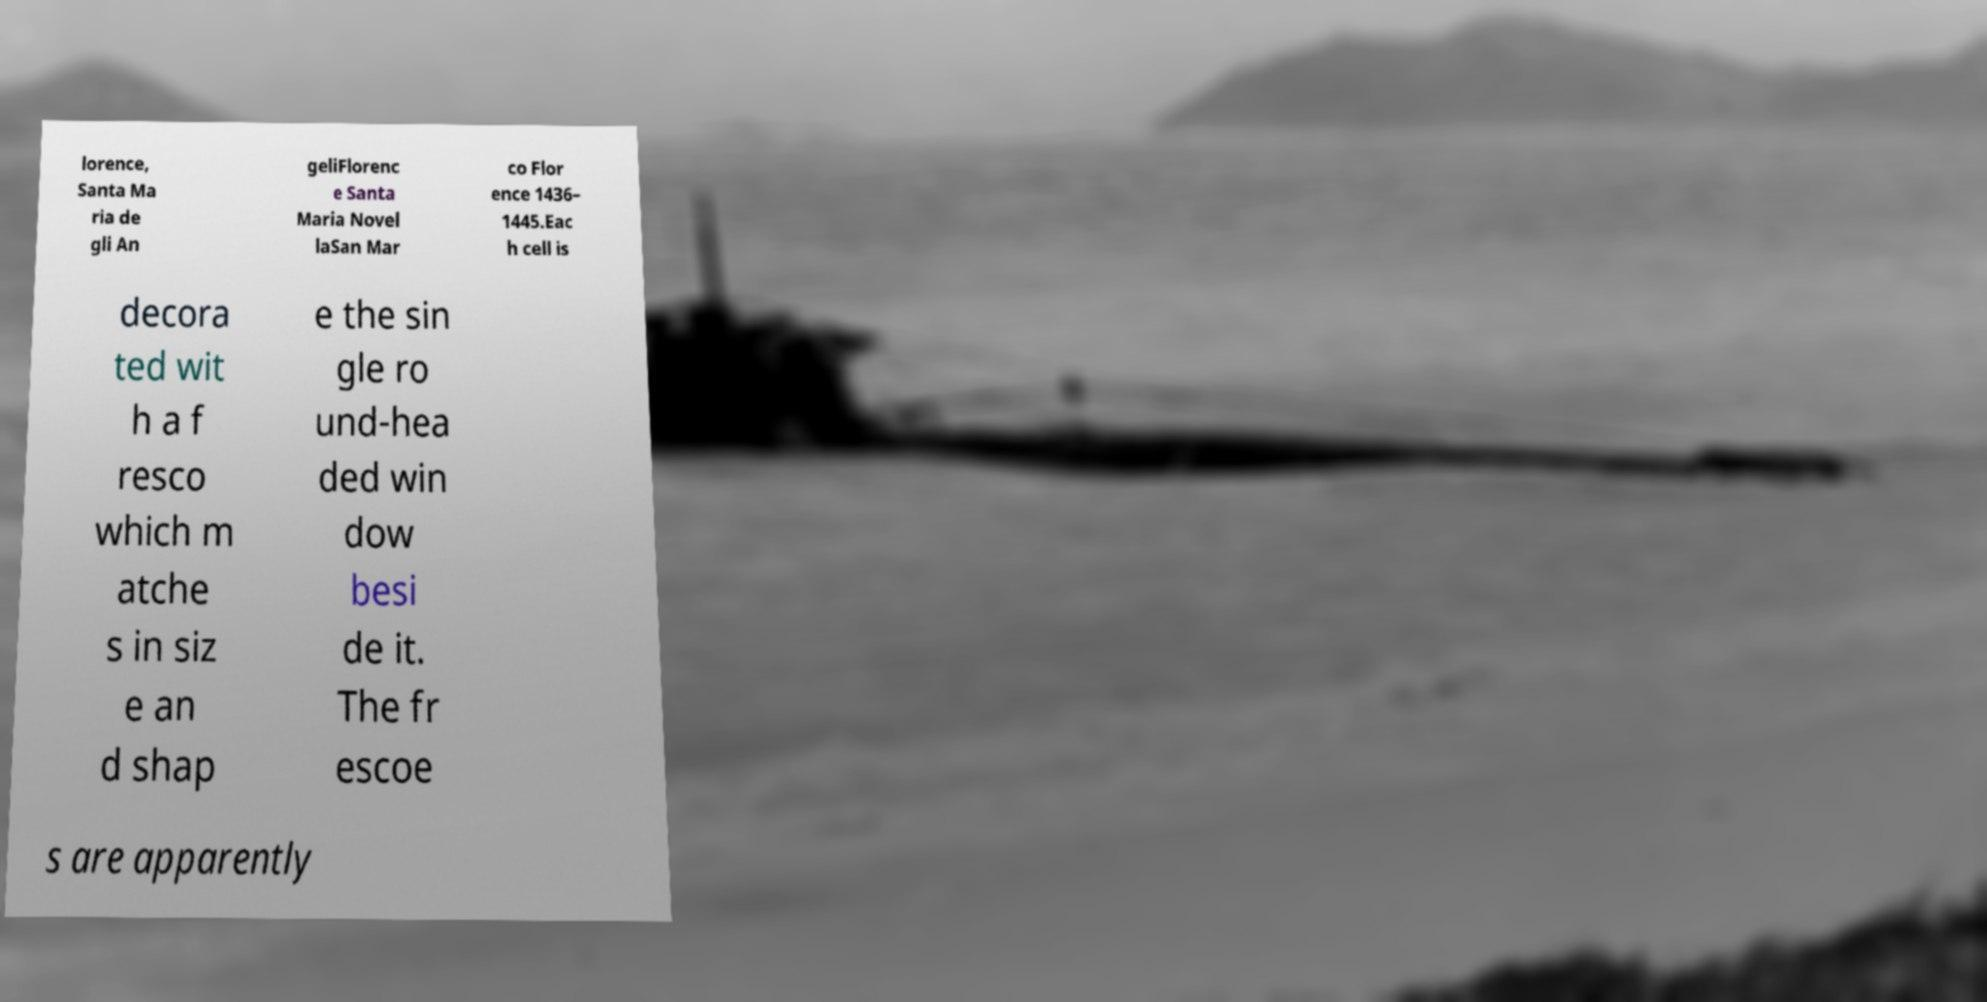Could you assist in decoding the text presented in this image and type it out clearly? lorence, Santa Ma ria de gli An geliFlorenc e Santa Maria Novel laSan Mar co Flor ence 1436– 1445.Eac h cell is decora ted wit h a f resco which m atche s in siz e an d shap e the sin gle ro und-hea ded win dow besi de it. The fr escoe s are apparently 